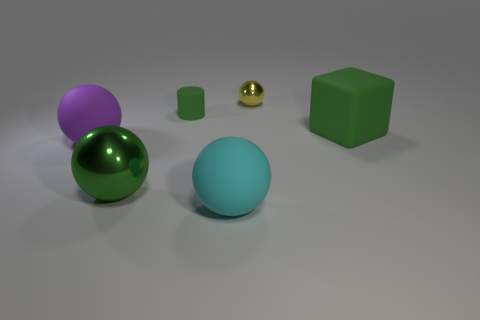Add 2 yellow shiny objects. How many objects exist? 8 Subtract all brown balls. Subtract all red cubes. How many balls are left? 4 Subtract all blocks. How many objects are left? 5 Add 4 large cyan matte things. How many large cyan matte things exist? 5 Subtract 0 red spheres. How many objects are left? 6 Subtract all blue metallic spheres. Subtract all big green rubber cubes. How many objects are left? 5 Add 1 tiny green objects. How many tiny green objects are left? 2 